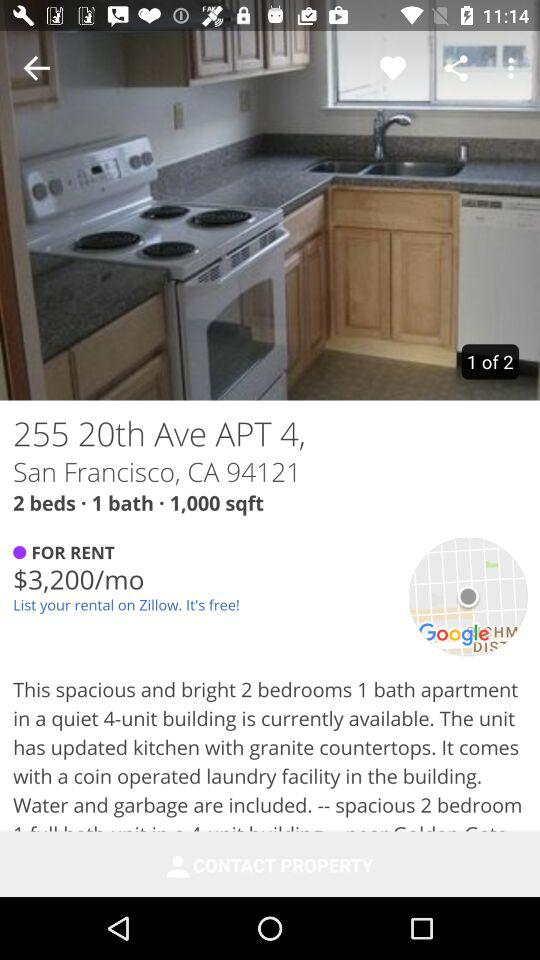How many bedrooms are in the property?
Answer the question using a single word or phrase. 2 